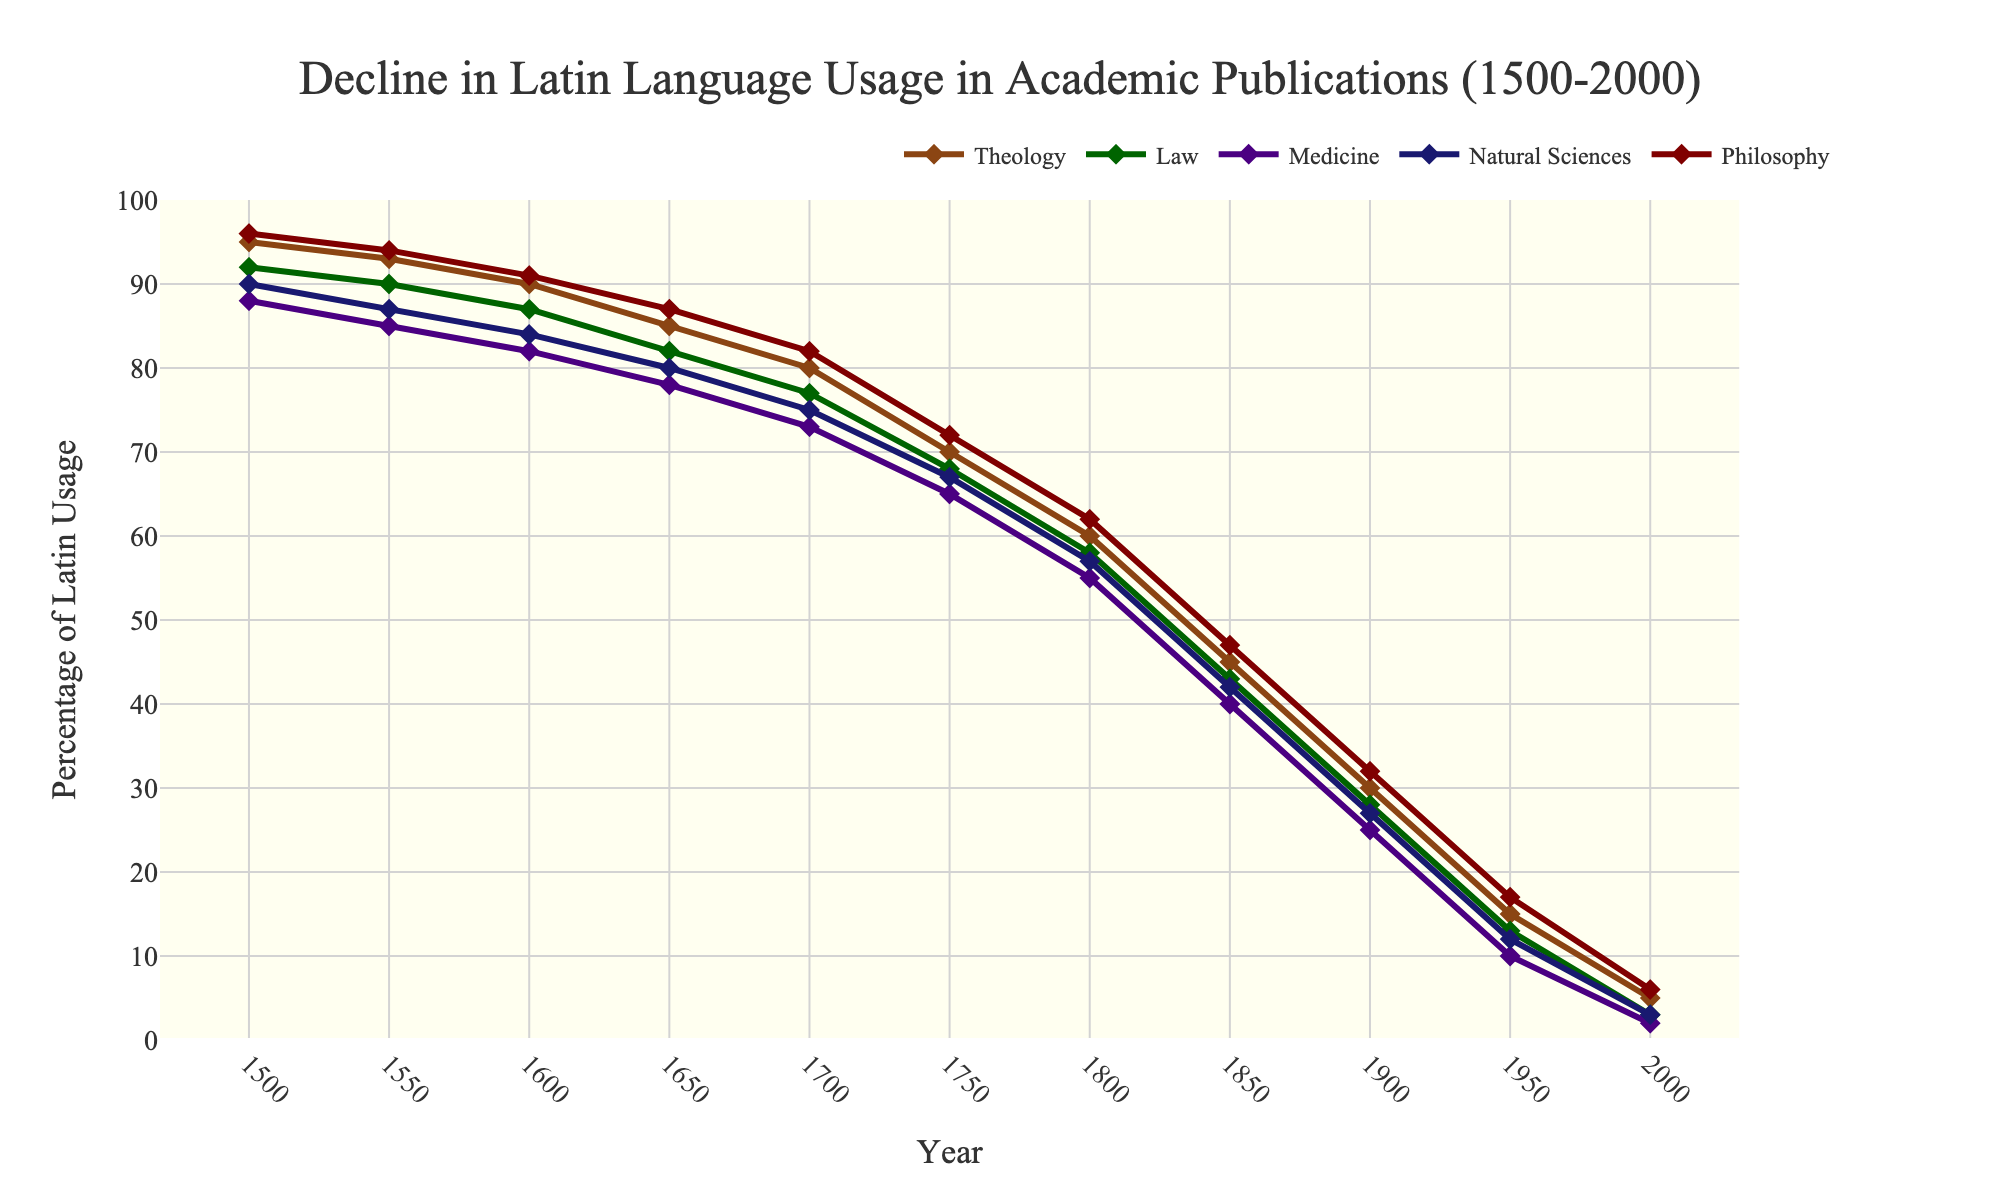Which field shows the most rapid decline in Latin language usage between 1500 and 2000? The field of Medicine shows the most rapid decline, dropping from 88% in 1500 to 2% in 2000.
Answer: Medicine In which year did Latin language usage fall below 50% for the first time in Theology? In 1800, Latin language usage in Theology fell to 60%, and by 1850 it was 45%. Thus, it fell below 50% between 1800 and 1850.
Answer: Between 1800 and 1850 Which fields intersect in terms of Latin usage around the year 1950? Around the year 1950, the Latin usage percentages of Medicine and Natural Sciences intersect at nearly the same value (approximately 10-12%).
Answer: Medicine and Natural Sciences What's the average Latin usage in academic publications across all fields in the year 1700? First, add the percentages for Theology (80%), Law (77%), Medicine (73%), Natural Sciences (75%), and Philosophy (82%). The total is 387%. Then, divide by the number of fields (5). The average is 387 / 5 = 77.4%.
Answer: 77.4% How much did the Latin usage decline in the field of Law between 1500 and 2000? Latin usage in the field of Law declined from 92% in 1500 to 3% in 2000. The decline is 92% - 3% = 89%.
Answer: 89% Which field has the lowest percentage of Latin usage in 2000, and what is that percentage? In 2000, the field of Medicine has the lowest percentage of Latin usage at 2%.
Answer: Medicine, 2% Which field maintains the highest Latin usage throughout the time span from 1500 to 2000? Throughout the entire time span, Theology maintains the highest Latin usage, starting from 95% in 1500 and still being the highest at 5% in 2000 compared to other fields.
Answer: Theology In which decade did the Latin usage in the Natural Sciences drop below the threshold of 50% for the first time? Latin usage in the Natural Sciences dropped below 50% for the first time in the 1850s, as it was 42% in 1850 and higher than 50% in 1800.
Answer: 1850s 